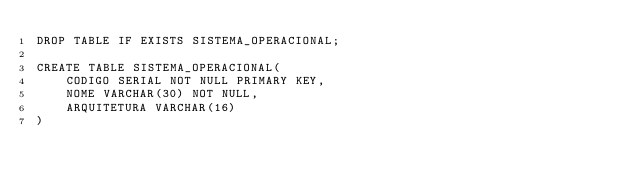Convert code to text. <code><loc_0><loc_0><loc_500><loc_500><_SQL_>DROP TABLE IF EXISTS SISTEMA_OPERACIONAL;

CREATE TABLE SISTEMA_OPERACIONAL(
	CODIGO SERIAL NOT NULL PRIMARY KEY,
	NOME VARCHAR(30) NOT NULL,
	ARQUITETURA VARCHAR(16)
)
</code> 